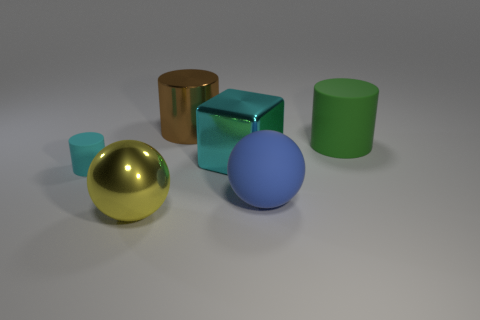Are there any other things that are the same size as the cyan matte thing?
Provide a succinct answer. No. There is a matte cylinder that is behind the big cyan object; are there any big cyan blocks right of it?
Offer a very short reply. No. What color is the other rubber thing that is the same shape as the small cyan matte object?
Provide a short and direct response. Green. What number of small objects have the same color as the big metal cylinder?
Offer a terse response. 0. There is a large sphere behind the metallic thing that is in front of the matte cylinder in front of the large cube; what color is it?
Your answer should be compact. Blue. Are the large blue sphere and the large green thing made of the same material?
Offer a very short reply. Yes. Is the shape of the cyan metallic thing the same as the big green matte object?
Your answer should be compact. No. Is the number of objects on the left side of the large blue ball the same as the number of yellow balls left of the tiny matte thing?
Your answer should be compact. No. There is a large cylinder that is made of the same material as the large blue object; what color is it?
Your response must be concise. Green. How many small cylinders have the same material as the large cube?
Provide a succinct answer. 0. 